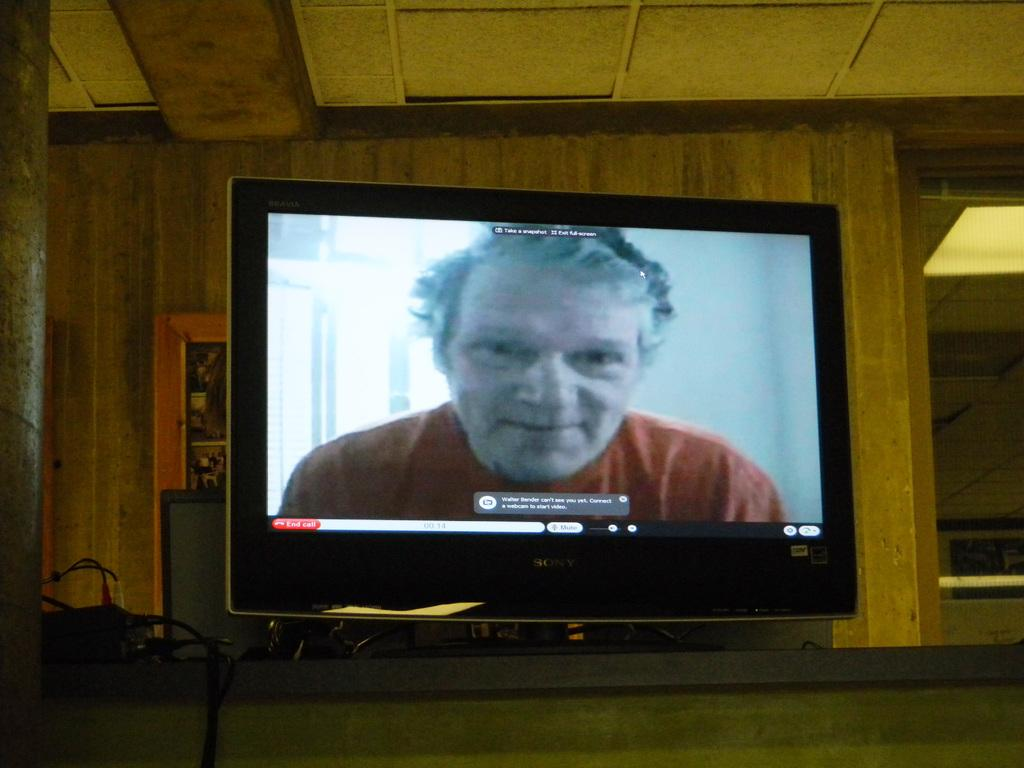<image>
Provide a brief description of the given image. A TV screen showing a man displays the message "Walter Bender can't see you yet. Connect a webcam to start video." 